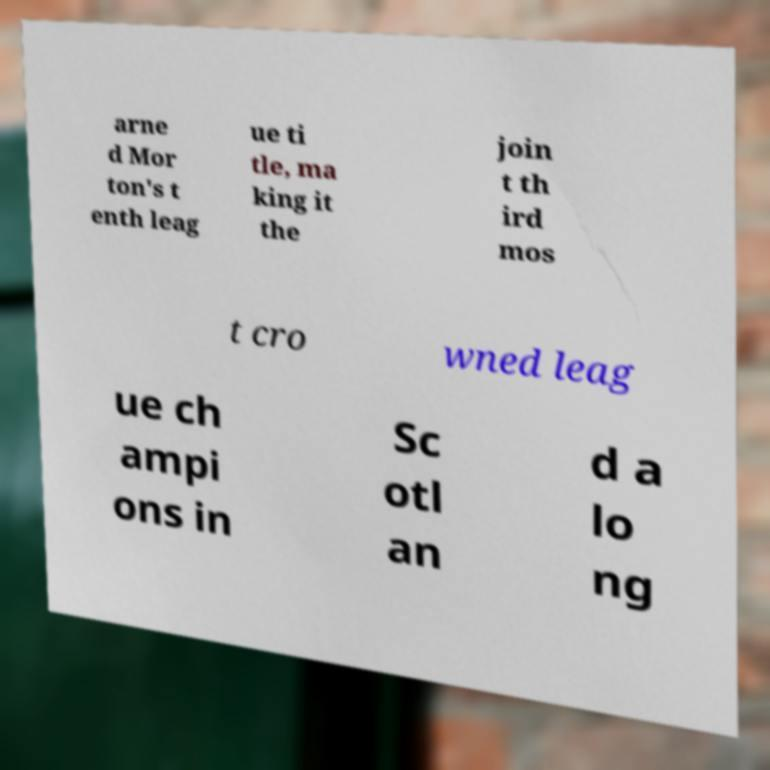Can you read and provide the text displayed in the image?This photo seems to have some interesting text. Can you extract and type it out for me? arne d Mor ton's t enth leag ue ti tle, ma king it the join t th ird mos t cro wned leag ue ch ampi ons in Sc otl an d a lo ng 